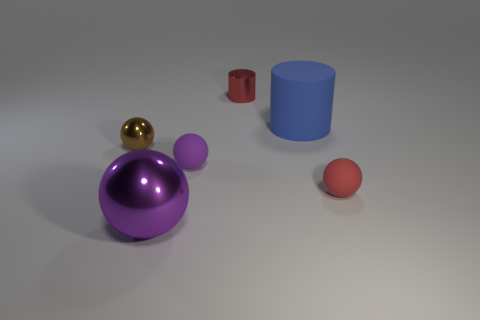There is a red thing that is the same size as the red sphere; what is its shape?
Make the answer very short. Cylinder. There is a small brown metal thing that is left of the big ball; how many red objects are in front of it?
Give a very brief answer. 1. How many other things are made of the same material as the big purple thing?
Keep it short and to the point. 2. What is the shape of the purple object that is behind the purple sphere that is in front of the red sphere?
Provide a short and direct response. Sphere. What is the size of the cylinder that is on the left side of the blue matte cylinder?
Make the answer very short. Small. Does the red cylinder have the same material as the brown ball?
Give a very brief answer. Yes. What is the shape of the tiny red thing that is made of the same material as the small purple object?
Offer a terse response. Sphere. Is there anything else that is the same color as the large rubber cylinder?
Your answer should be very brief. No. The tiny metallic thing in front of the blue cylinder is what color?
Provide a short and direct response. Brown. Do the tiny metallic thing that is behind the brown metal object and the large cylinder have the same color?
Provide a short and direct response. No. 